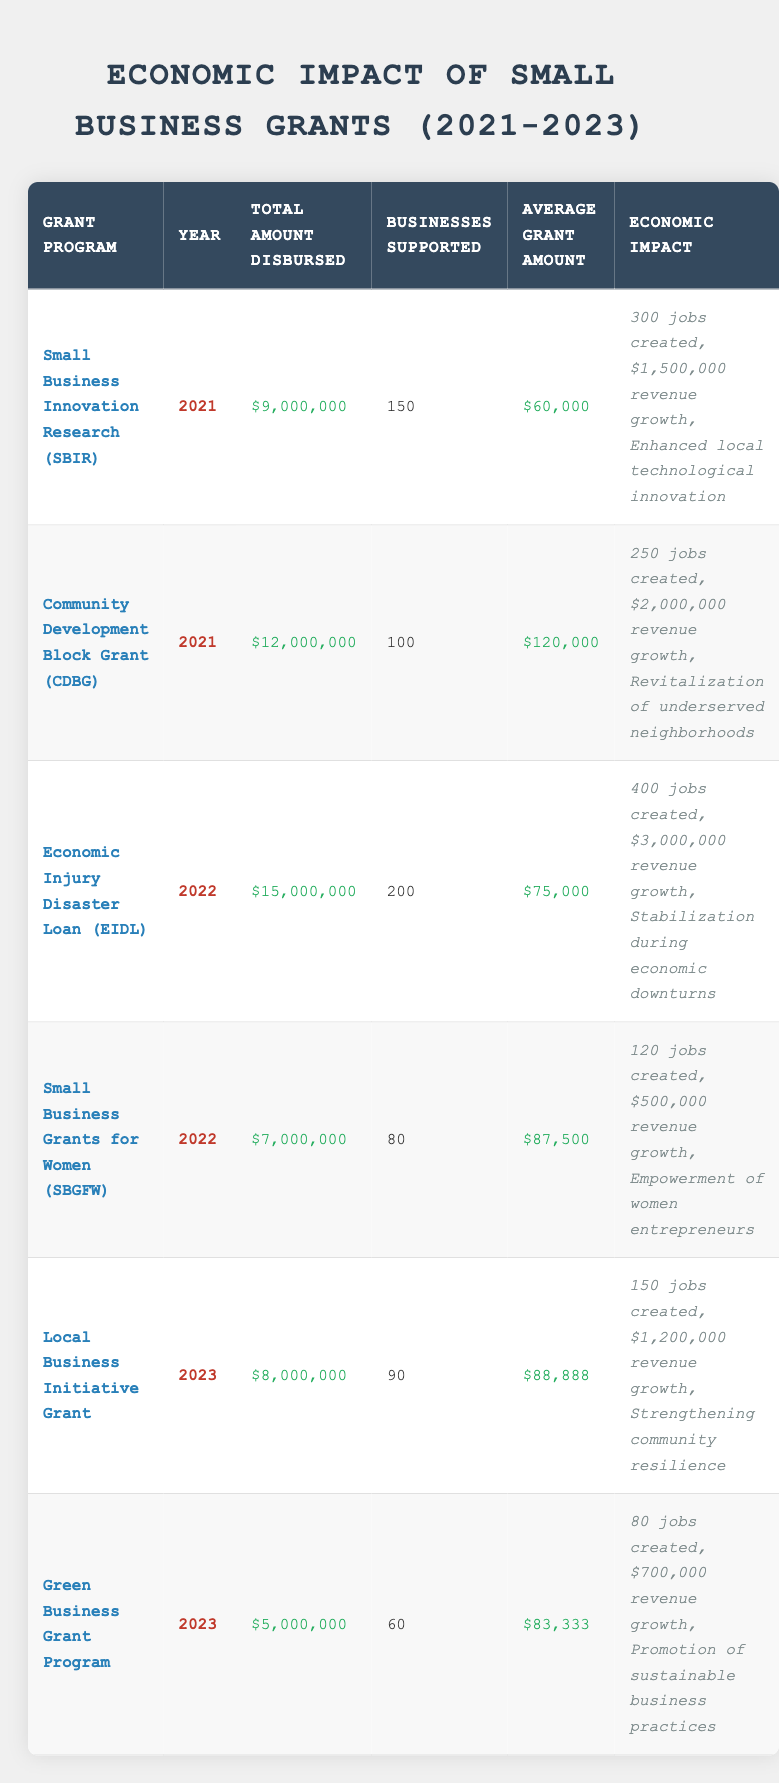What was the total amount disbursed for the Community Development Block Grant in 2021? According to the table, the total amount disbursed for the Community Development Block Grant in 2021 is listed as $12,000,000.
Answer: $12,000,000 How many businesses were supported by the Economic Injury Disaster Loan in 2022? The table indicates that the Economic Injury Disaster Loan supported 200 businesses in 2022.
Answer: 200 What is the average grant amount for the Green Business Grant Program in 2023? The Green Business Grant Program in 2023 shows an average grant amount of $83,333 according to the table.
Answer: $83,333 Which grant program created the most jobs in 2022? By examining the jobs created within the 2022 entries, the Economic Injury Disaster Loan created the most jobs, listed as 400 in the table.
Answer: Economic Injury Disaster Loan What is the total revenue growth reported from all grant programs in 2021? To find this, we sum the revenue growth from the two grant programs in 2021: $1,500,000 (SBIR) + $2,000,000 (CDBG) = $3,500,000.
Answer: $3,500,000 Did the Local Business Initiative Grant support more businesses than the Green Business Grant Program in 2023? The Local Business Initiative Grant supported 90 businesses while the Green Business Grant Program supported 60 businesses in 2023. Therefore, yes, it supported more businesses.
Answer: Yes What is the difference in total amount disbursed between the Economic Injury Disaster Loan and Small Business Grants for Women in 2022? The difference is calculated by subtracting the amount disbursed for Small Business Grants for Women from that of the Economic Injury Disaster Loan: $15,000,000 (EIDL) - $7,000,000 (SBGFW) = $8,000,000.
Answer: $8,000,000 Which grant program had the highest average grant amount in 2021? Comparing the average grant amounts in 2021, the Community Development Block Grant had the highest average grant amount of $120,000 listed, surpassing SBIR’s $60,000.
Answer: Community Development Block Grant How many total jobs were created across all grant programs in 2023? Summing the jobs created for both programs in 2023: 150 (Local Business Initiative Grant) + 80 (Green Business Grant Program) = 230 total jobs created.
Answer: 230 